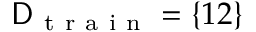<formula> <loc_0><loc_0><loc_500><loc_500>D _ { t r a i n } = \{ 1 2 \}</formula> 